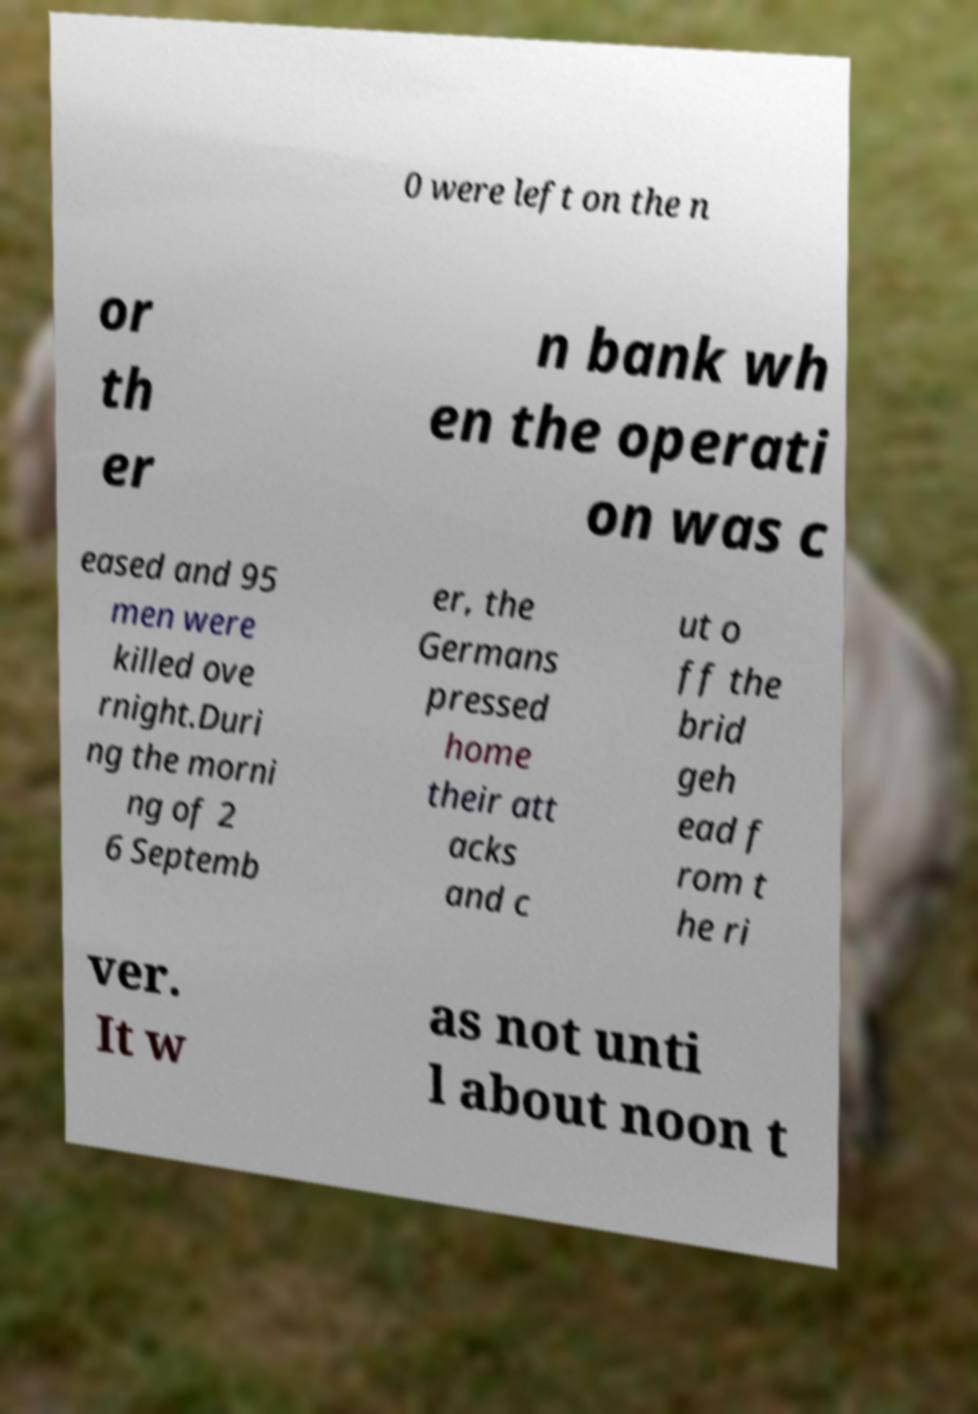I need the written content from this picture converted into text. Can you do that? 0 were left on the n or th er n bank wh en the operati on was c eased and 95 men were killed ove rnight.Duri ng the morni ng of 2 6 Septemb er, the Germans pressed home their att acks and c ut o ff the brid geh ead f rom t he ri ver. It w as not unti l about noon t 